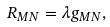<formula> <loc_0><loc_0><loc_500><loc_500>R _ { M N } = \lambda g _ { M N } ,</formula> 